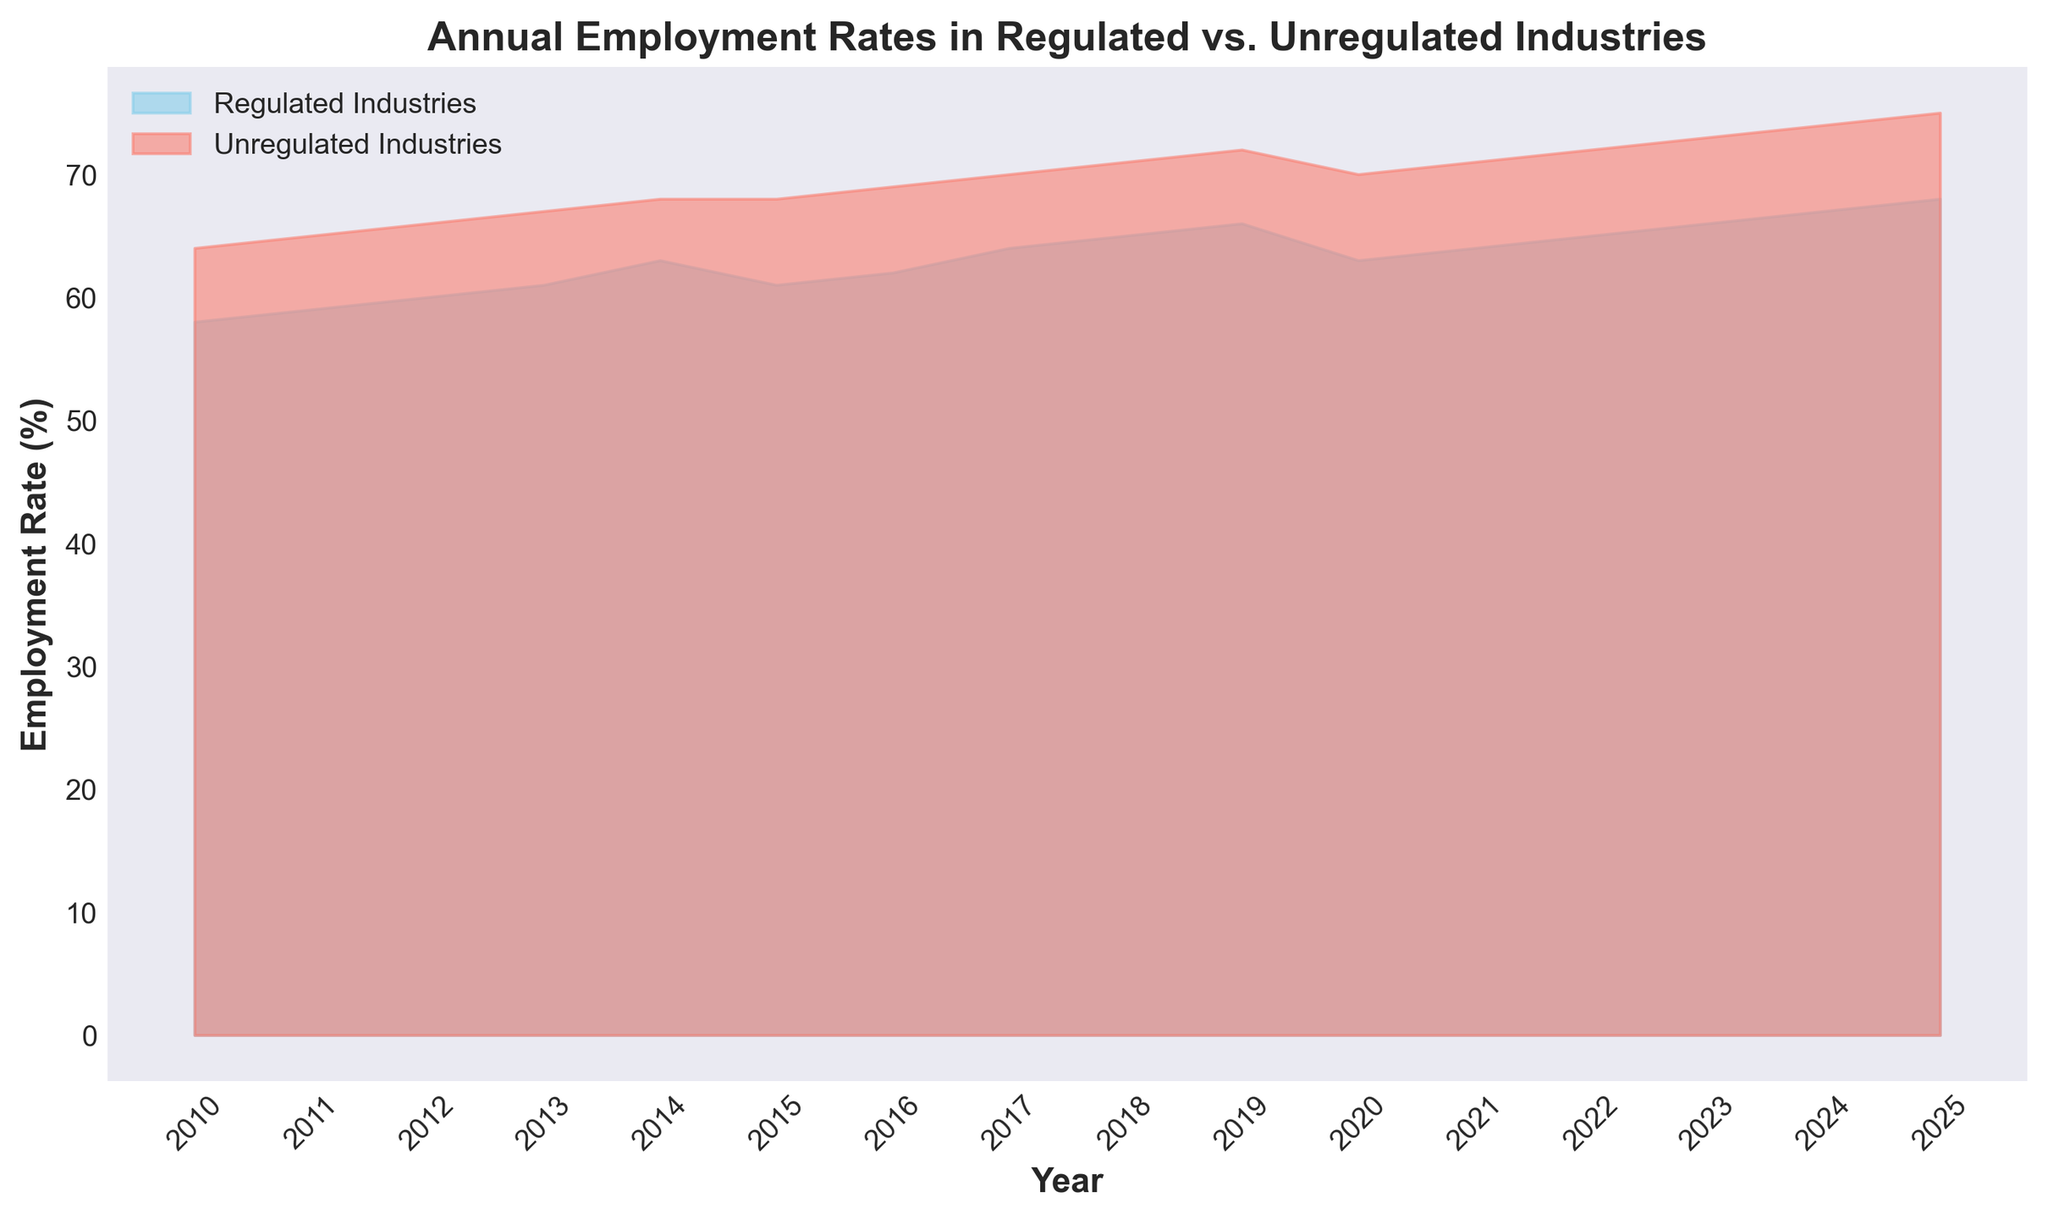What is the difference in employment rates between regulated and unregulated industries in 2015? To find the difference in employment rates between regulated and unregulated industries in 2015, identify the respective rates for each category. For 2015, the employment rate for regulated industries is 61%, and for unregulated industries, it is 68%. Subtract the regulated rate from the unregulated rate: 68% - 61% = 7%.
Answer: 7% Which industry saw a higher employment rate increase from 2010 to 2025? First, find the employment rates for regulated industries in 2010 (58%) and 2025 (68%). The increase is 68% - 58% = 10%. Next, find the rates for unregulated industries in 2010 (64%) and 2025 (75%). The increase is 75% - 64% = 11%. Compare the increases: 11% (unregulated) is higher than 10% (regulated).
Answer: Unregulated Industries What is the average employment rate for regulated industries between 2012 and 2016? Identify the employment rates for regulated industries from 2012 to 2016: 60%, 61%, 63%, 61%, and 62%. Sum these values: 60 + 61 + 63 + 61 + 62 = 307. Divide the sum by the number of years: 307 / 5 = 61.4%.
Answer: 61.4% In which year was there the smallest gap between employment rates of regulated and unregulated industries? Find the difference in employment rates for each year: 
2010: 64-58=6,
2011: 65-59=6,
2012: 66-60=6,
2013: 67-61=6,
2014: 68-63=5,
2015: 68-61=7,
2016: 69-62=7,
2017: 70-64=6,
2018: 71-65=6,
2019: 72-66=6,
2020: 70-63=7,
2021: 71-64=7,
2022: 72-65=7,
2023: 73-66=7,
2024: 74-67=7,
2025: 75-68=7.
The smallest gap is in 2014 (5%).
Answer: 2014 Describe the trend for regulated industries' employment rates from 2010 to 2015. From 2010, the employment rate for regulated industries shows a general increasing trend. Starting at 58% in 2010, the rate steadily increases each year, reaching 63% in 2014. A slight decrease occurs in 2015, with the rate dropping to 61%.
Answer: Increasing with a slight drop in 2015 In which years did employment rates in regulated industries remain constant? Identify the years where the employment rate does not change for regulated industries. The rate is 61% in both 2015 and 2016.
Answer: 2015 and 2016 How did employment rates in unregulated industries change from 2021 to 2023? The employment rates for unregulated industries in the years 2021 to 2023 are as follows: 71% in 2021, 72% in 2022, and 73% in 2023. This indicates a steady increase of 1% each year.
Answer: Increased steadily What is the visual difference between the areas representing regulated and unregulated industries? The area representing regulated industries is shaded in sky blue, while the area for unregulated industries is shaded in salmon. The height difference, represented by color saturation, shows unregulated industries generally have higher employment rates.
Answer: Unregulated has higher rates and is in salmon, regulated is in sky blue Which industry showed more variability in annual employment rates throughout the period? Examine the yearly employment rates' fluctuations. Regulated industries have variations from 58% to 68%. Unregulated industries range from 64% to 75%. The range for unregulated industries (75-64=11%) is slightly greater than for regulated (68-58=10%).
Answer: Unregulated Industries 